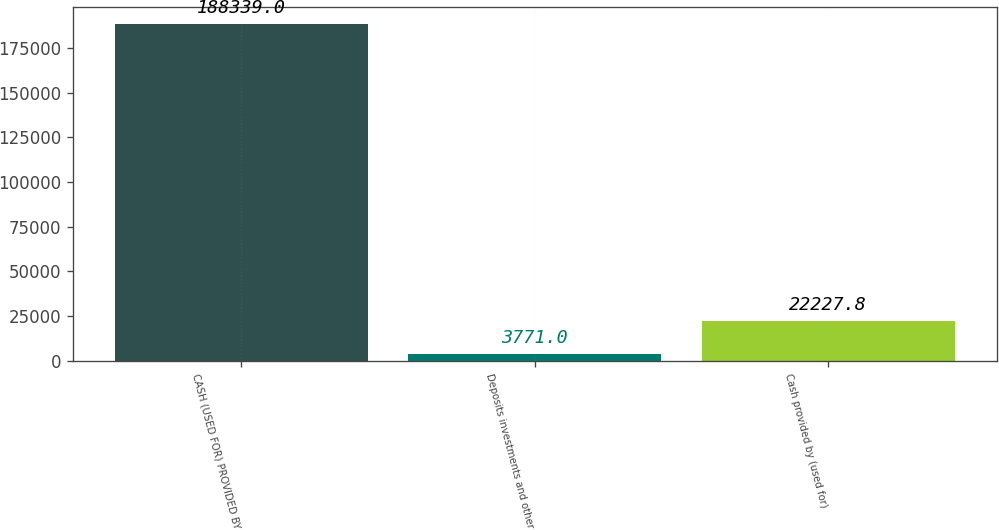Convert chart. <chart><loc_0><loc_0><loc_500><loc_500><bar_chart><fcel>CASH (USED FOR) PROVIDED BY<fcel>Deposits investments and other<fcel>Cash provided by (used for)<nl><fcel>188339<fcel>3771<fcel>22227.8<nl></chart> 